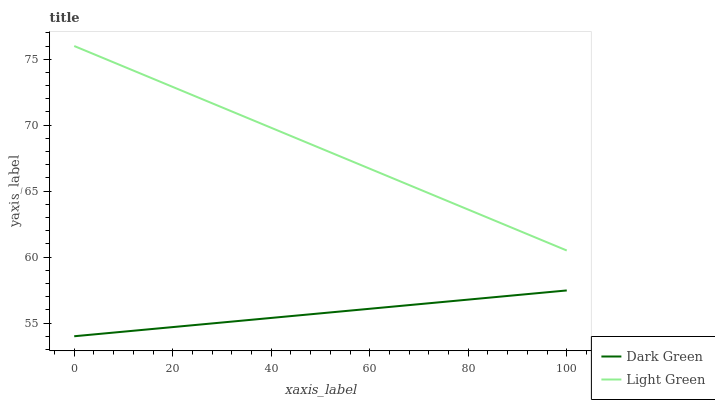Does Dark Green have the minimum area under the curve?
Answer yes or no. Yes. Does Light Green have the maximum area under the curve?
Answer yes or no. Yes. Does Dark Green have the maximum area under the curve?
Answer yes or no. No. Is Light Green the smoothest?
Answer yes or no. Yes. Is Dark Green the roughest?
Answer yes or no. Yes. Is Dark Green the smoothest?
Answer yes or no. No. Does Light Green have the highest value?
Answer yes or no. Yes. Does Dark Green have the highest value?
Answer yes or no. No. Is Dark Green less than Light Green?
Answer yes or no. Yes. Is Light Green greater than Dark Green?
Answer yes or no. Yes. Does Dark Green intersect Light Green?
Answer yes or no. No. 